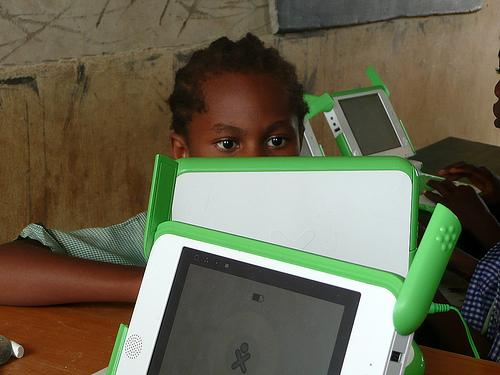Identify an object on the table related to writing or drawing. White chalk is on the table. List three visible features of the young kid in the main scene. Brown eyes, hair in braids, and wearing a green shirt. Count the number of computer monitors visible in the image. There are two green and white computer monitors. Describe the appearance of the wall present in the scene. The wall is a tan cement wall with scratches and marks. What is the color and state of the computer screen with a visible symbol on it? The computer screen has a gray color with an X symbol in the center. Can you describe an object connected to the computer in the image? There's a green electrical cord connected to the computer. What color is the shirt of the young kid in the image? The young kid is wearing a green shirt. What is the young kid in the background doing in the image? The young kid in the background is typing on a computer. How is the young kid's hair styled in the image? The young kid's hair is styled in braids. Mention an accessory visible on the computer. A removable portion of a laptop case is visible. What color is the laptop case in the image? Green Choose the correct description of the computer screen from these options: A) Gray with an X in the center, B) White with an X in the center, C) Blue with an X in the center A) Gray with an X in the center Does the person with cornrows have long, curly hair? The person in the image has cornrows, not long and curly hair. What color is the computer monitor in the image? Answer:  Is the brown table actually made of plastic material? The table in the image is described as wooden, not plastic. Identify the type of device on which the kid is typing? Keyboard Is the computer screen displaying a blue background with a white X in the center? The computer screen is described as gray, not displaying a blue background. Explain the activity being performed by the young kid. Typing on a computer Is the green and white shirt sleeve actually yellow and white? The actual color of the shirt sleeve is green and white, not yellow and white. Is there any writing instrument in the image? White chalk Is the child accompanied by someone else? Another young kid is in the background List the items connected to the laptop. Green electrical cord Identify any marks or imperfections in the scene. Scratches on the wall and a small dent Provide a brief description of the scene. Young kid typing on a computer while wearing a green and white shirt with braided hair. What is the color of the young kid's eyes? Brown Describe the table in the image. The table is wooden and brown. Is the half of the young kid's face that is visible showing their mouth and chin area? The visible half of their face is the upper half (eyes and up), not the lower mouth and chin area. Is the young kid wearing a red shirt, rather than a green one? The young kid is described as wearing a green shirt, not a red one. Explain the condition of the wall in the image. Scratches on a brown cement wall What is the screen showing on the laptop? Gray screen with an X in the center. Is there more than one object connected to the computer? No What is the kid wearing on their upper body? Green and white shirt What kind of hairstyle does the child have in the image? Braids Identify the location of the scene in the image. A classroom with a brown wall 